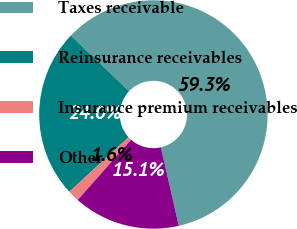Convert chart to OTSL. <chart><loc_0><loc_0><loc_500><loc_500><pie_chart><fcel>Taxes receivable<fcel>Reinsurance receivables<fcel>Insurance premium receivables<fcel>Other<nl><fcel>59.29%<fcel>23.98%<fcel>1.64%<fcel>15.1%<nl></chart> 